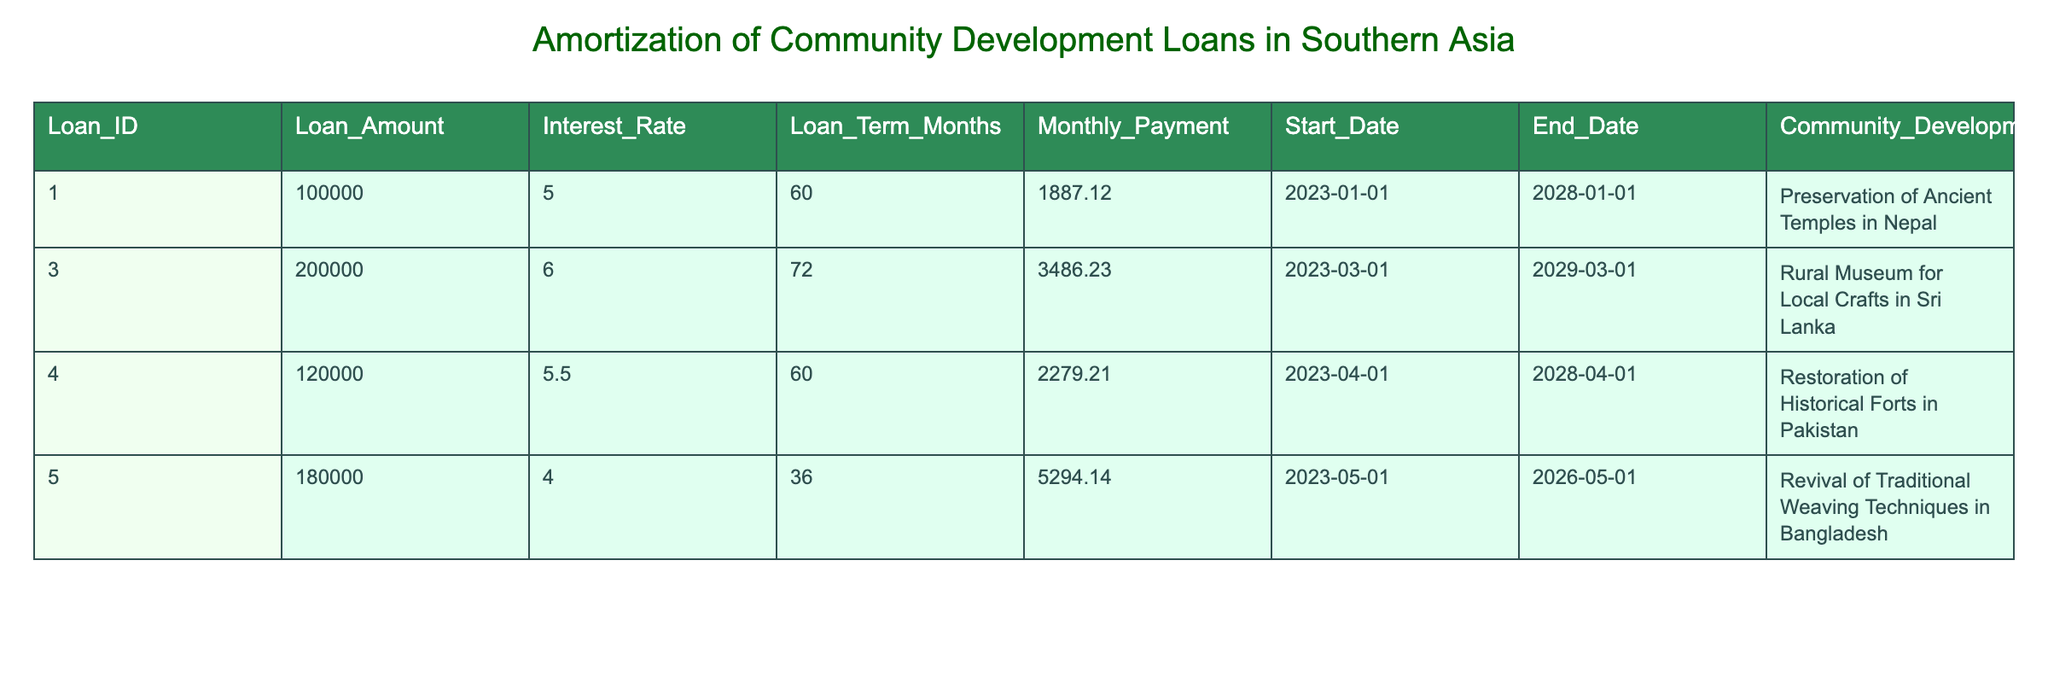What is the loan amount for the Preservation of Ancient Temples in Nepal? From the table, I can see that the loan amount corresponding to the project "Preservation of Ancient Temples in Nepal" is listed under the Loan Amount column. It is specifically $100,000.
Answer: 100000 Which community development project has the highest monthly payment? By comparing the Monthly Payment values across all projects, I find that the project with the highest monthly payment is "Revival of Traditional Weaving Techniques in Bangladesh," which has a monthly payment of $5,294.14.
Answer: Revival of Traditional Weaving Techniques in Bangladesh What is the total loan amount for all the projects listed? To find the total loan amount, I need to sum the loan amounts from all projects: 100000 + 200000 + 120000 + 180000 = 600000. Therefore, the total loan amount across all projects is $600,000.
Answer: 600000 Is the interest rate for the Rural Museum for Local Crafts in Sri Lanka lower than 6.5%? Checking the Interest Rate for the project "Rural Museum for Local Crafts in Sri Lanka," it is 6.0%. Since 6.0% is less than 6.5%, the answer is yes.
Answer: Yes Which loan has the shortest term in months, and what is that term? By looking at the Loan Term Months column, I find that "Revival of Traditional Weaving Techniques in Bangladesh" has the shortest term at 36 months.
Answer: 36 